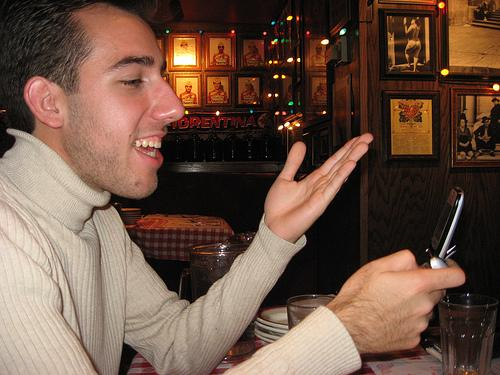Question: what pattern are the table cloths?
Choices:
A. Gingham.
B. Plaid.
C. Polkadots.
D. Checkered.
Answer with the letter. Answer: D Question: what type of shirt is the man wearing?
Choices:
A. A sweater.
B. Turtle neck.
C. A tshirt.
D. A tank top.
Answer with the letter. Answer: B Question: what is the man holding?
Choices:
A. A tablet.
B. A book.
C. A dog.
D. A phone.
Answer with the letter. Answer: D Question: where is this picture taken?
Choices:
A. On the beach.
B. A restaurant.
C. Inside of a house.
D. Out in the street.
Answer with the letter. Answer: B Question: how many plates are on the table?
Choices:
A. 5.
B. 6.
C. 4.
D. 7.
Answer with the letter. Answer: C 